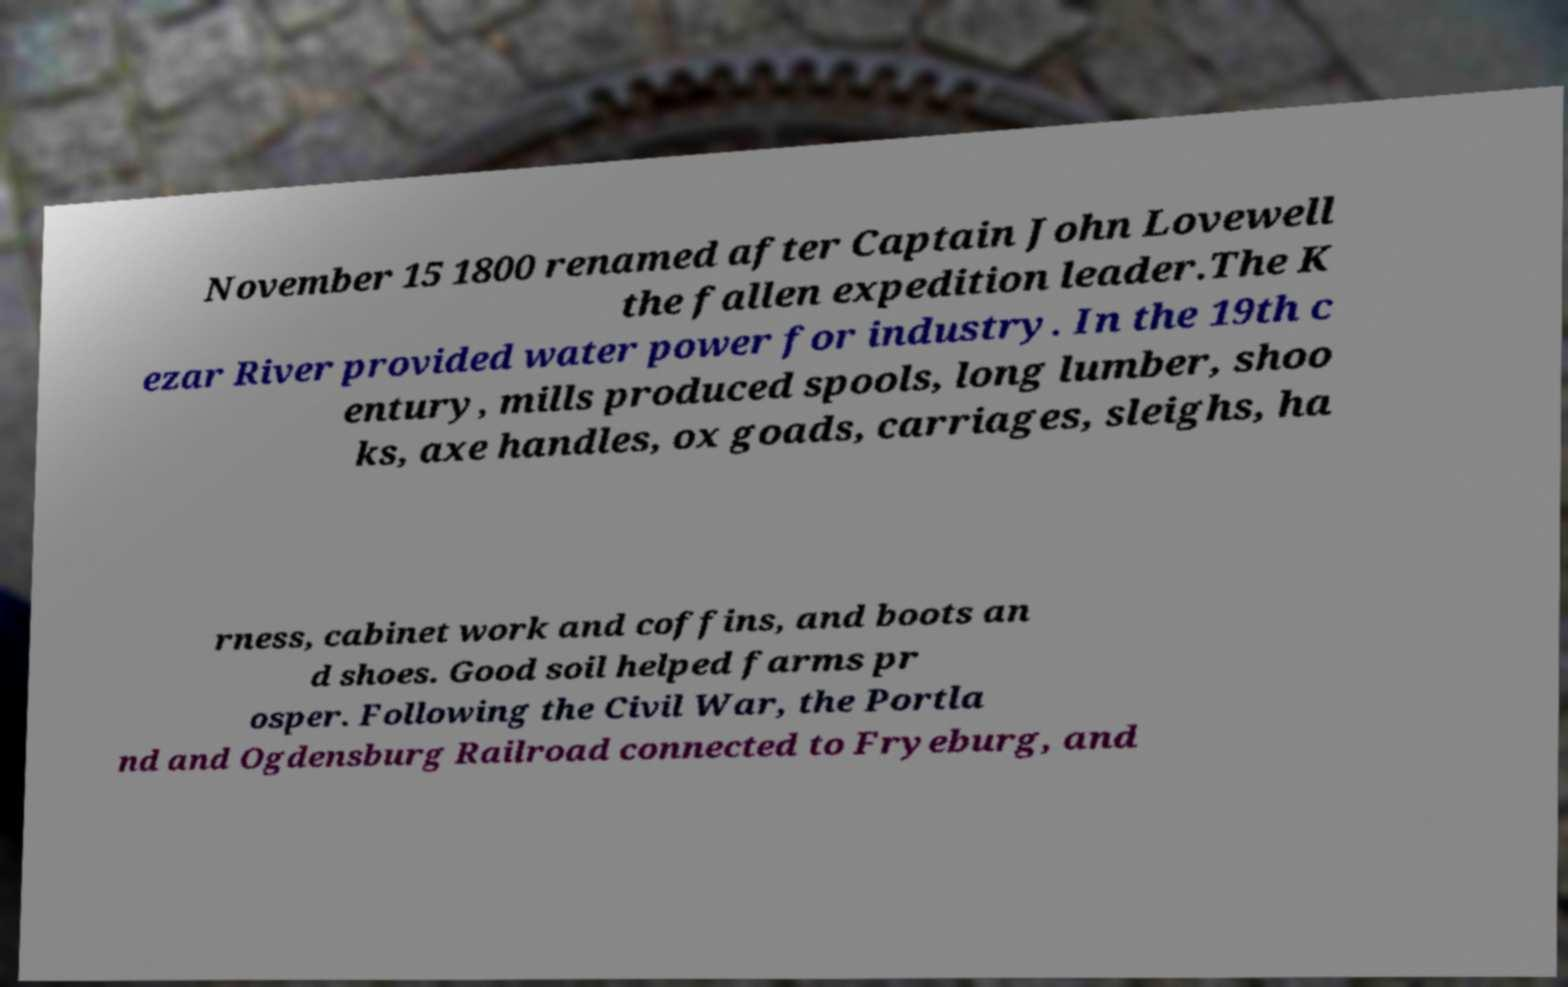Please read and relay the text visible in this image. What does it say? November 15 1800 renamed after Captain John Lovewell the fallen expedition leader.The K ezar River provided water power for industry. In the 19th c entury, mills produced spools, long lumber, shoo ks, axe handles, ox goads, carriages, sleighs, ha rness, cabinet work and coffins, and boots an d shoes. Good soil helped farms pr osper. Following the Civil War, the Portla nd and Ogdensburg Railroad connected to Fryeburg, and 